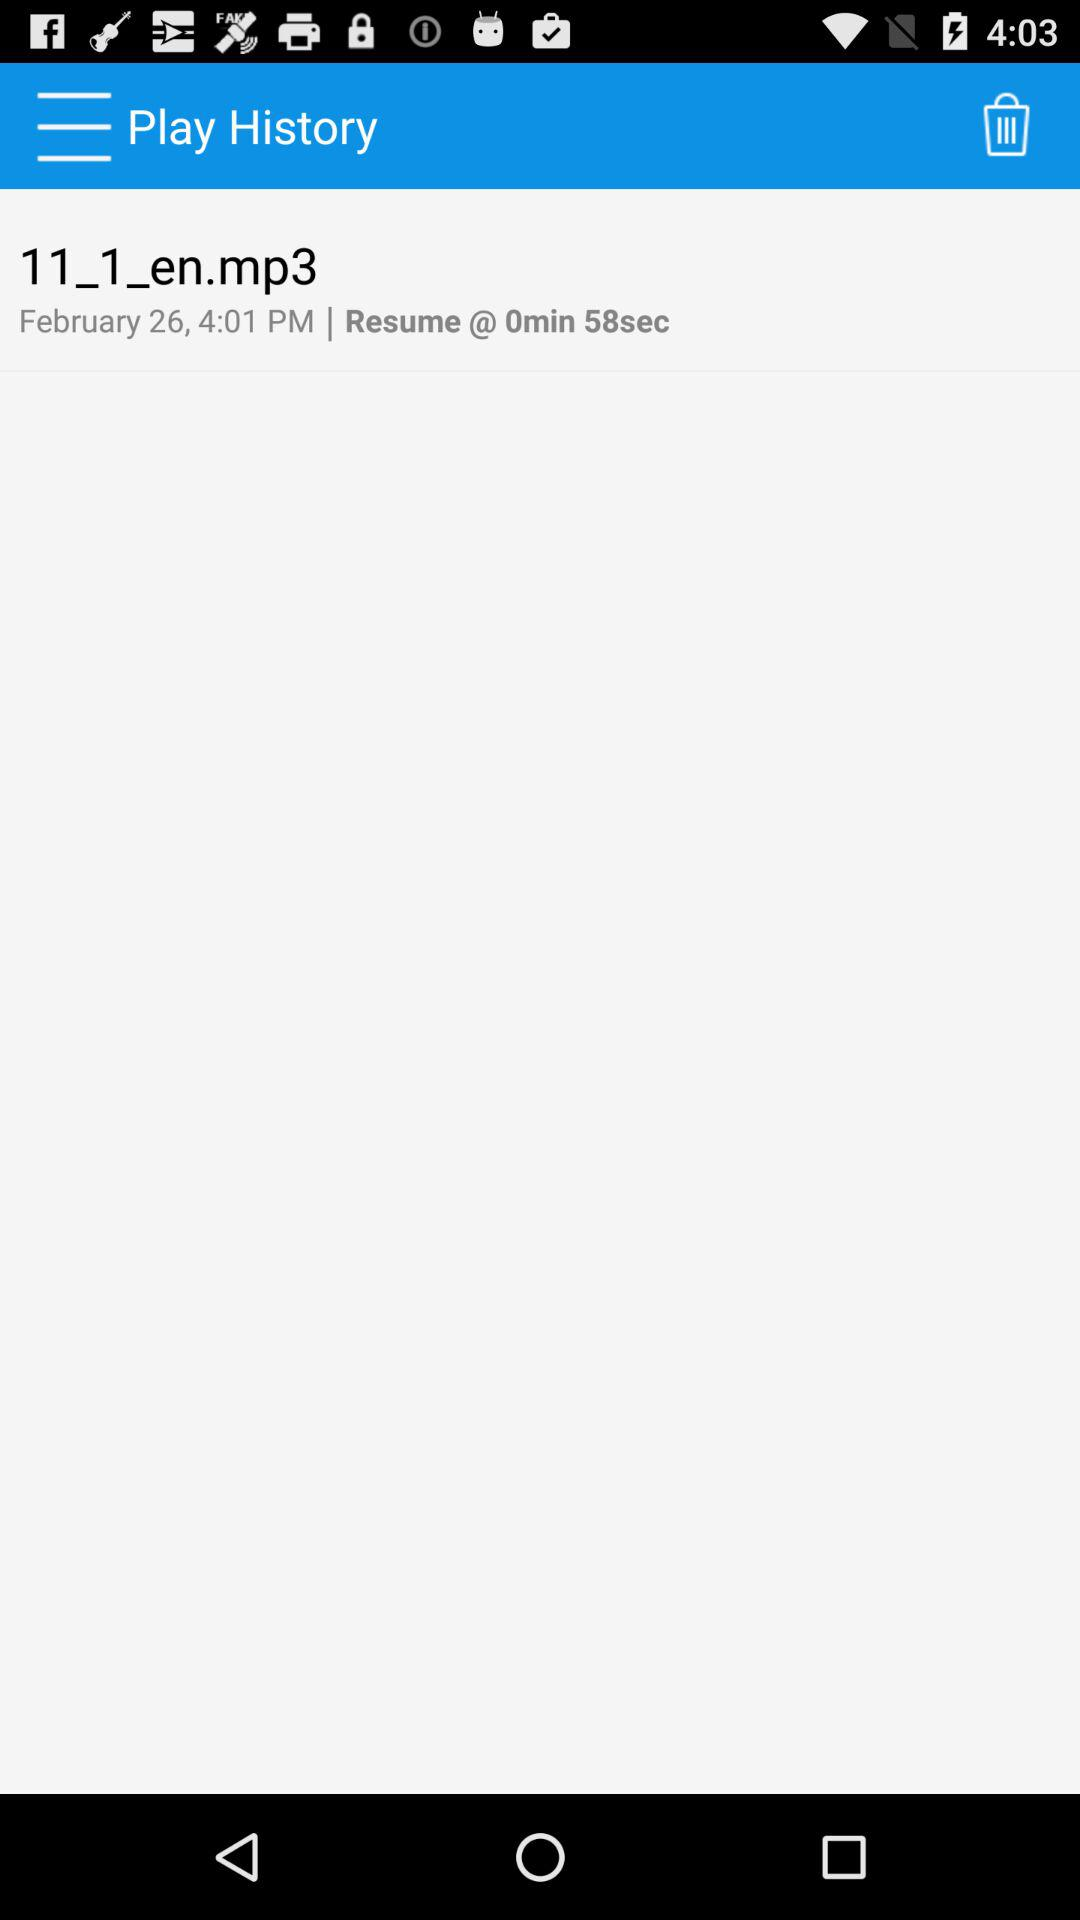What is the name of the given mp3 file? The name of the given mp3 file is "11_1_en.mp3". 